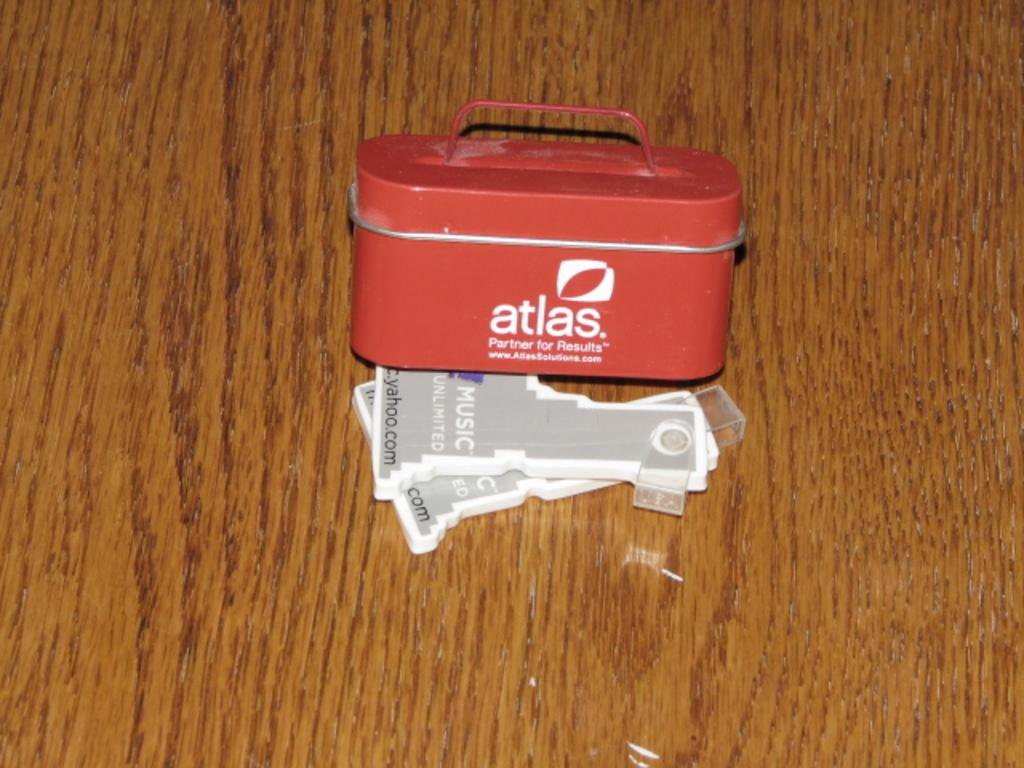<image>
Provide a brief description of the given image. an Atlas canister on top a wooden table 